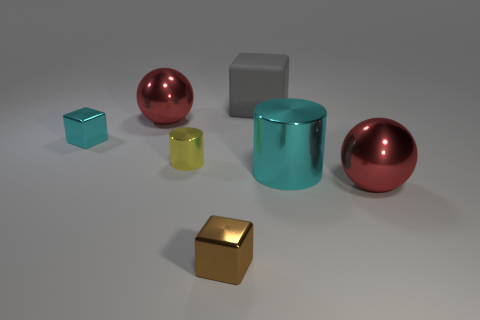Subtract all tiny metal cubes. How many cubes are left? 1 Add 3 tiny brown metallic cubes. How many objects exist? 10 Subtract all cyan blocks. How many blocks are left? 2 Subtract all cylinders. How many objects are left? 5 Subtract all big gray shiny balls. Subtract all red metal spheres. How many objects are left? 5 Add 5 small cubes. How many small cubes are left? 7 Add 2 metallic cylinders. How many metallic cylinders exist? 4 Subtract 0 yellow spheres. How many objects are left? 7 Subtract 1 spheres. How many spheres are left? 1 Subtract all yellow blocks. Subtract all green spheres. How many blocks are left? 3 